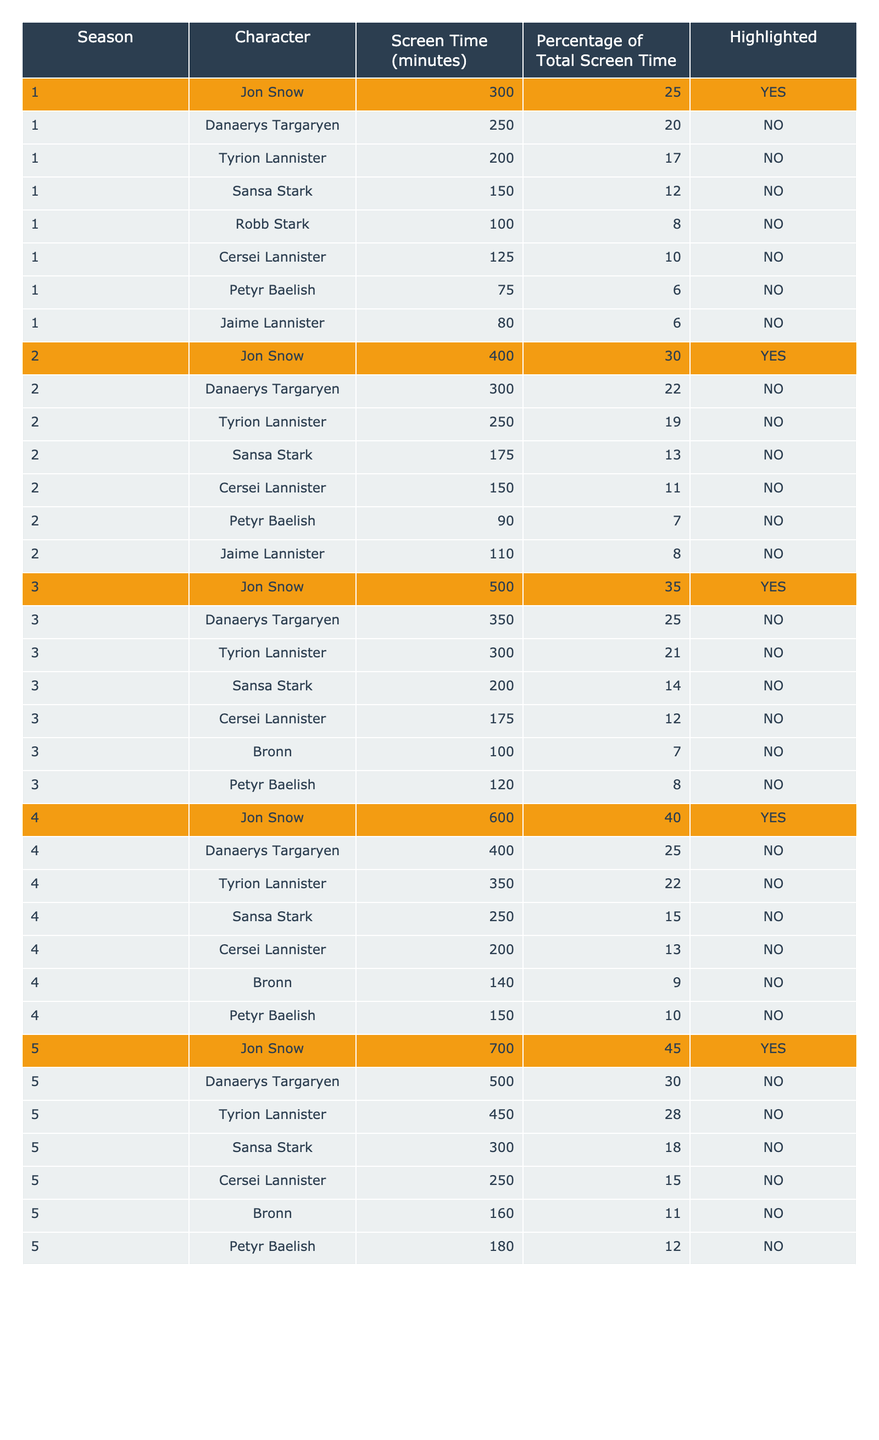What is the total screen time of Jon Snow across all seasons? To find Jon Snow's total screen time, we add up his screen time from all seasons: 300 + 400 + 500 + 600 + 700 = 2500 minutes.
Answer: 2500 minutes Which character has the highest percentage of total screen time in Season 4? In Season 4, Jon Snow has the highest percentage, which is 40%. This can be found in the table under Season 4, Character, and Percentage of Total Screen Time.
Answer: 40% How much screen time did Danaerys Targaryen receive in Season 3? Danaerys Targaryen received 350 minutes of screen time in Season 3, as listed in the table under Season 3 and Danaerys Targaryen's row.
Answer: 350 minutes What is the average screen time of Tyrion Lannister across all seasons? Tyrion's screen times are 200, 250, 300, 350, and 450 minutes across the five seasons. The sum is 200 + 250 + 300 + 350 + 450 = 1550, and there are 5 data points, so the average is 1550 / 5 = 310.
Answer: 310 minutes Did Sansa Stark appear more in Season 2 or Season 5? In Season 2, Sansa Stark had 175 minutes of screen time, whereas in Season 5, she had 300 minutes. Therefore, she appeared more in Season 5. This is confirmed by directly comparing the screen times from both seasons in the table.
Answer: Yes, more in Season 5 What is the difference in screen time between Jon Snow in Season 5 and Season 3? Jon Snow had 700 minutes in Season 5 and 500 minutes in Season 3. The difference is 700 - 500 = 200 minutes.
Answer: 200 minutes Is Cersei Lannister's screen time in Season 1 greater than that in Season 4? Cersei had 125 minutes in Season 1 and 200 minutes in Season 4. Since 200 is greater than 125, she had more screen time in Season 4.
Answer: Yes, more in Season 4 What percentage of total screen time did Petyr Baelish have in Season 1? In Season 1, Petyr Baelish had 75 minutes of screen time, which constituted 6% of the total screen time for that season as per the table.
Answer: 6% Which character consistently had their screen time highlighted across seasons? Jon Snow consistently had his screen time highlighted across all seasons listed in the table by being marked 'YES' in the Highlighted column every time.
Answer: Jon Snow 